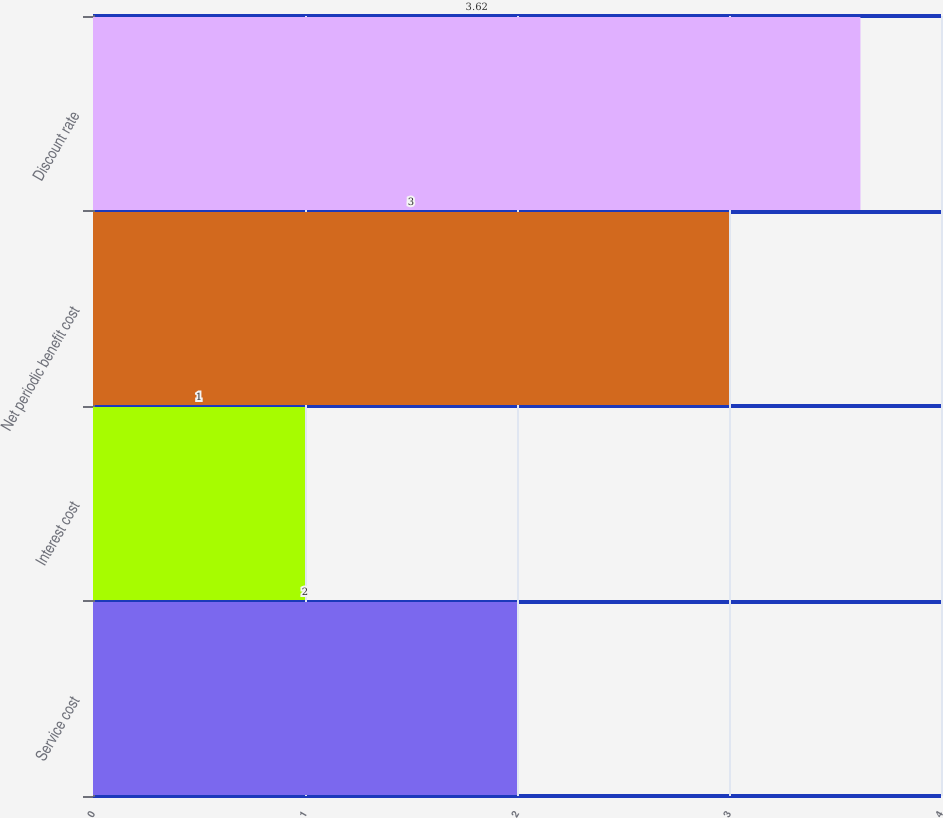Convert chart. <chart><loc_0><loc_0><loc_500><loc_500><bar_chart><fcel>Service cost<fcel>Interest cost<fcel>Net periodic benefit cost<fcel>Discount rate<nl><fcel>2<fcel>1<fcel>3<fcel>3.62<nl></chart> 